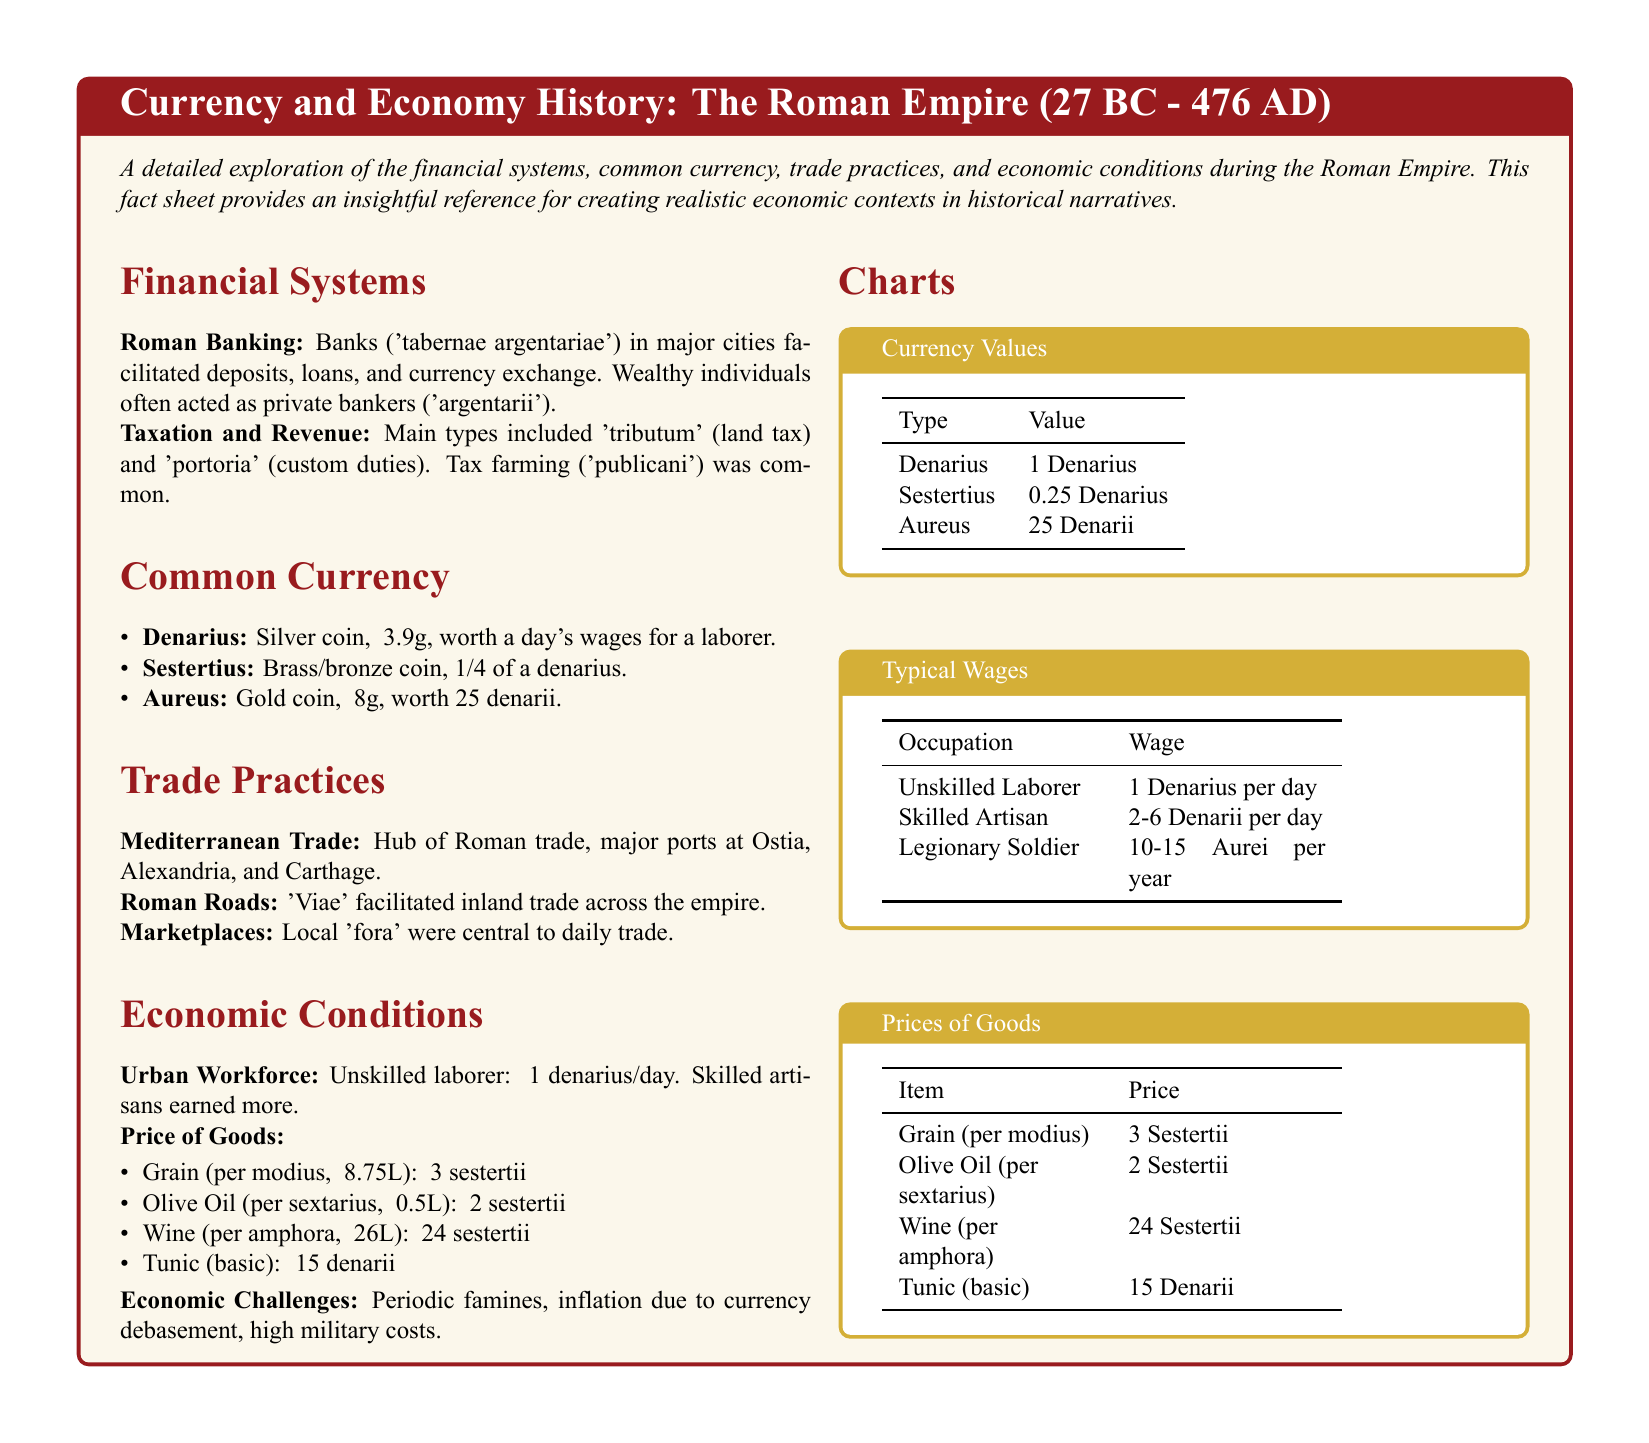What is the primary silver coin used in the Roman Empire? The document states that the primary silver coin is the Denarius.
Answer: Denarius How much did unskilled laborers earn per day? The document specifies that unskilled laborers earned about 1 Denarius per day.
Answer: 1 Denarius What type of tax was 'tributum'? The document describes 'tributum' as a land tax.
Answer: Land tax What was the price of an amphora of wine? According to the document, the price of an amphora of wine was 24 Sestertii.
Answer: 24 Sestertii How many Denarii is one Aureus worth? The document indicates that one Aureus is worth 25 Denarii.
Answer: 25 Denarii What facilitated inland trade across the empire? The document mentions that Roman roads ('Viae') facilitated inland trade across the empire.
Answer: Roman roads Which city is mentioned as a major port for Mediterranean trade? The document lists Alexandria as a major port for Mediterranean trade.
Answer: Alexandria What type of coin is a Sestertius made of? The document states that a Sestertius is made of brass or bronze.
Answer: Brass/Bronze What was a common economic challenge faced by the Roman Empire? The document highlights periodic famines as a common economic challenge.
Answer: Periodic famines 